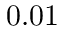Convert formula to latex. <formula><loc_0><loc_0><loc_500><loc_500>0 . 0 1</formula> 